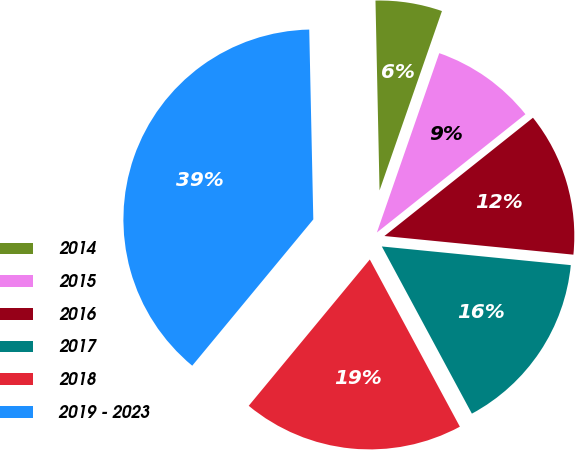<chart> <loc_0><loc_0><loc_500><loc_500><pie_chart><fcel>2014<fcel>2015<fcel>2016<fcel>2017<fcel>2018<fcel>2019 - 2023<nl><fcel>5.67%<fcel>8.97%<fcel>12.27%<fcel>15.57%<fcel>18.87%<fcel>38.66%<nl></chart> 